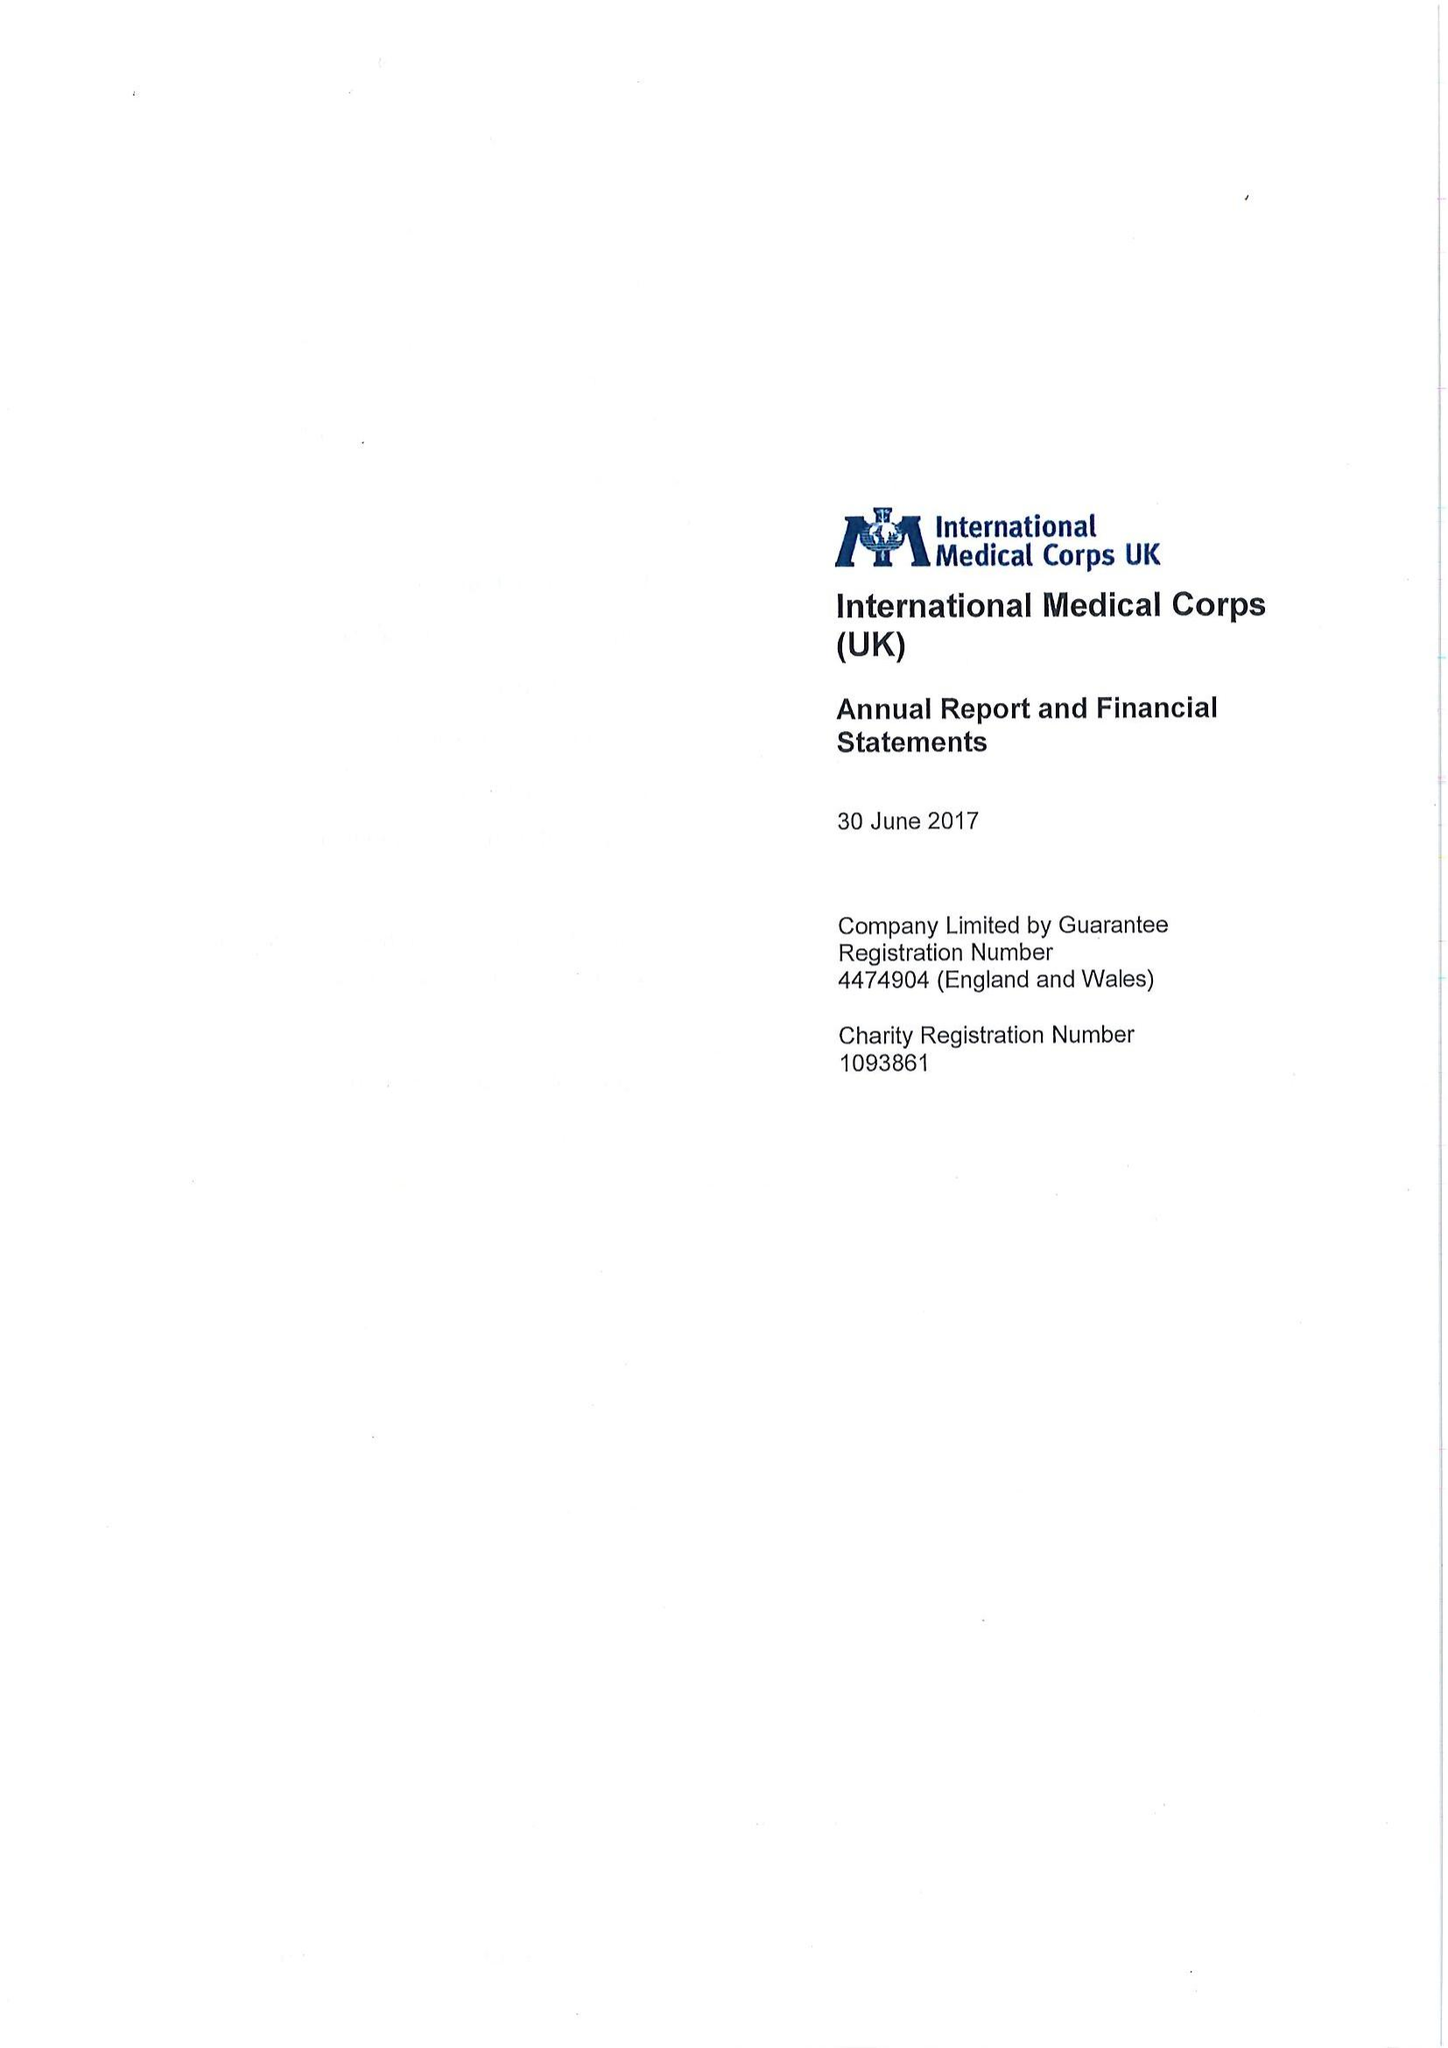What is the value for the address__postcode?
Answer the question using a single word or phrase. E14 9SJ 